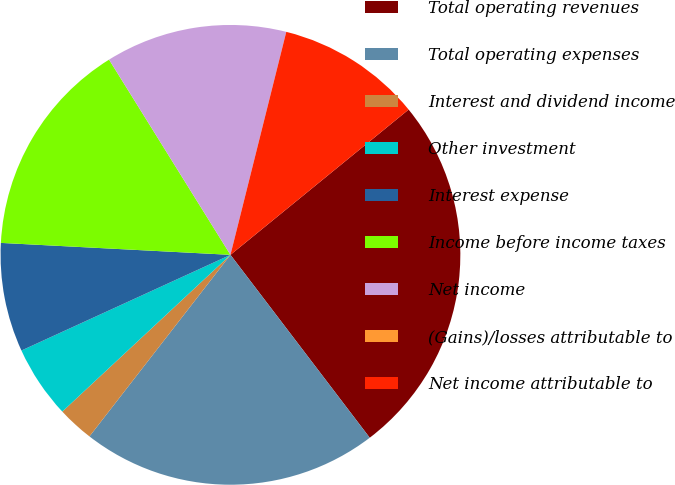<chart> <loc_0><loc_0><loc_500><loc_500><pie_chart><fcel>Total operating revenues<fcel>Total operating expenses<fcel>Interest and dividend income<fcel>Other investment<fcel>Interest expense<fcel>Income before income taxes<fcel>Net income<fcel>(Gains)/losses attributable to<fcel>Net income attributable to<nl><fcel>25.53%<fcel>20.87%<fcel>2.55%<fcel>5.11%<fcel>7.66%<fcel>15.32%<fcel>12.76%<fcel>0.0%<fcel>10.21%<nl></chart> 